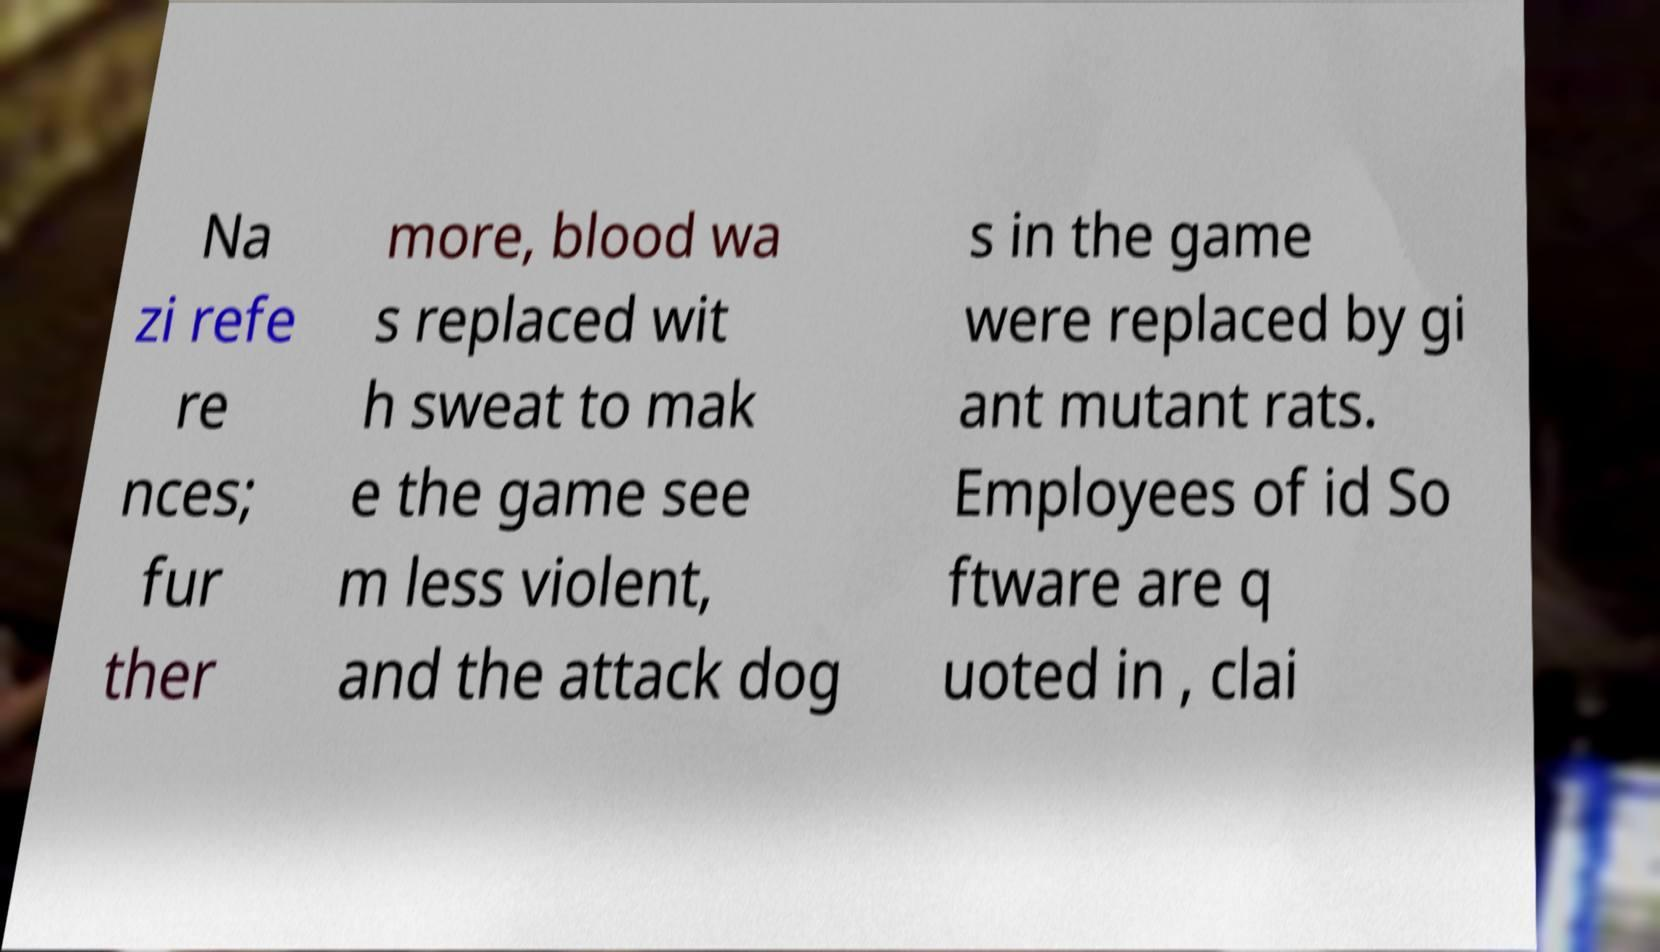What messages or text are displayed in this image? I need them in a readable, typed format. Na zi refe re nces; fur ther more, blood wa s replaced wit h sweat to mak e the game see m less violent, and the attack dog s in the game were replaced by gi ant mutant rats. Employees of id So ftware are q uoted in , clai 